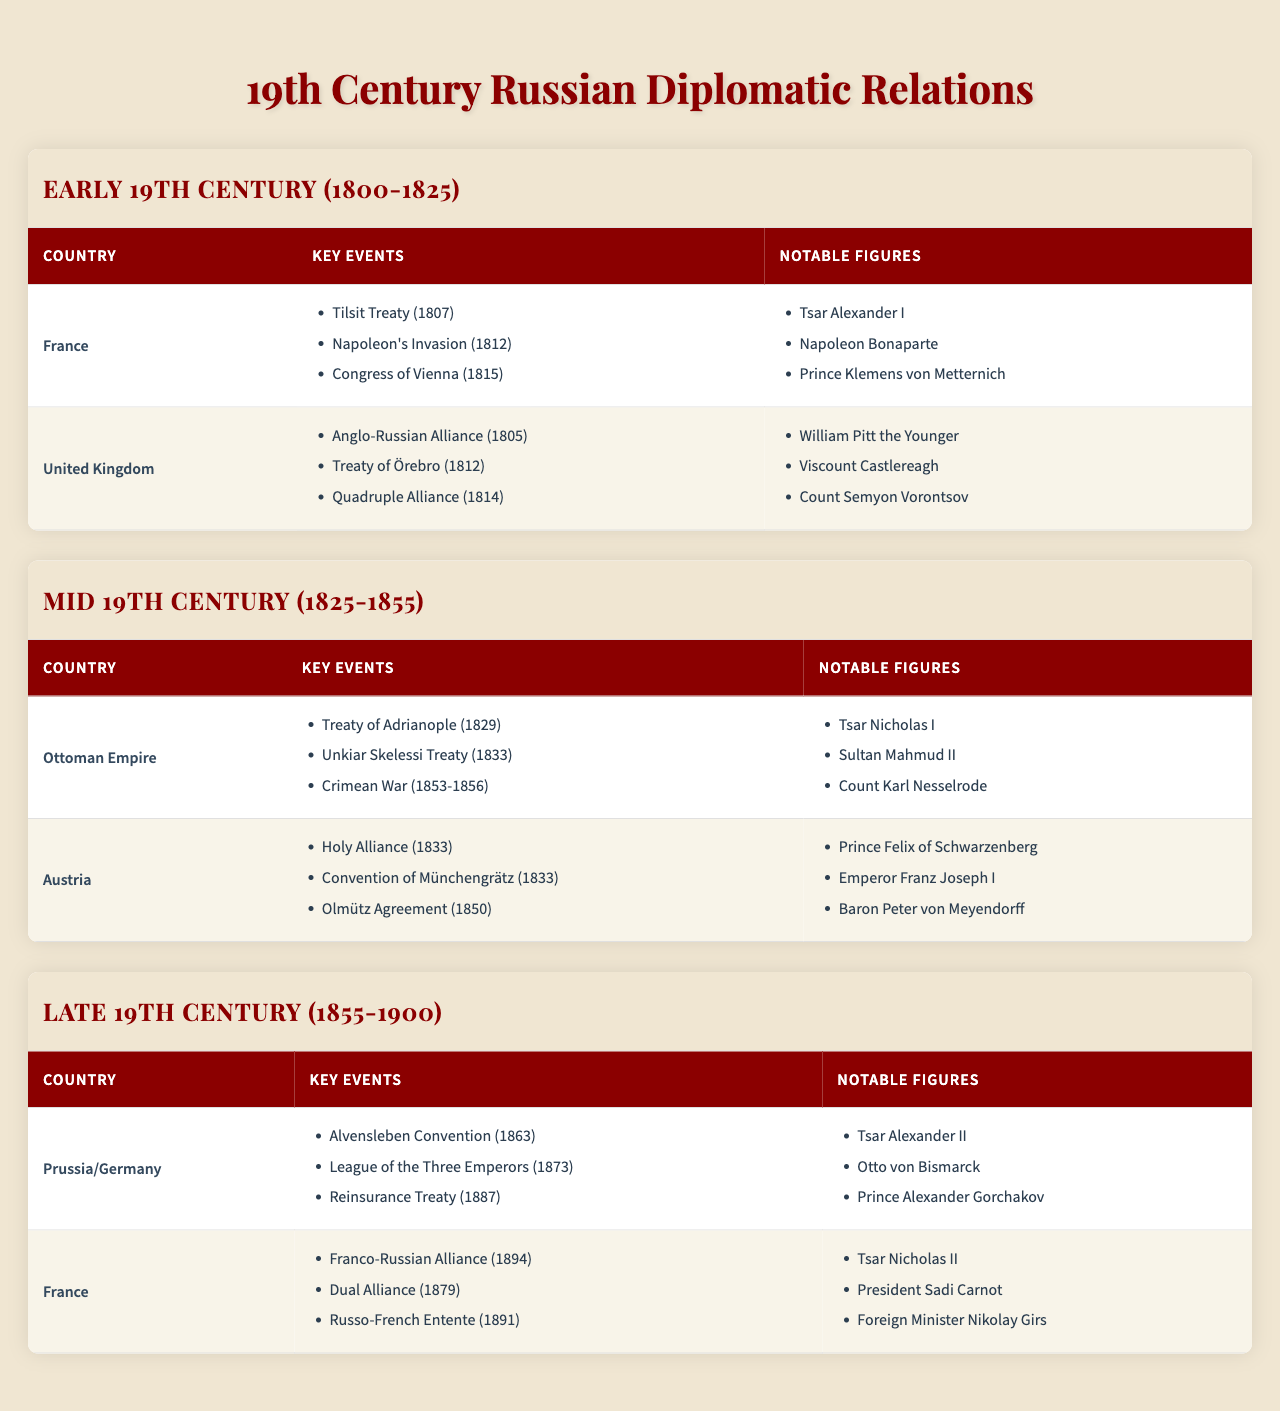What major treaty was signed between Russia and France in 1807? The table lists the key events in the early 19th century under the section for France, which includes the "Tilsit Treaty (1807)."
Answer: Tilsit Treaty Which notable figure was involved in the Treaty of Adrianople in 1829? The table indicates that the Treaty of Adrianople was signed during the mid 19th century, and under the Ottoman Empire, it lists "Tsar Nicholas I" as a notable figure.
Answer: Tsar Nicholas I Did the United Kingdom and Russia enter into any alliances during the early 19th century? Referring to the table under the United Kingdom section, it shows that they established the "Anglo-Russian Alliance (1805)." Therefore, yes, they did enter into alliances.
Answer: Yes How many key events are listed for Prussia/Germany in the late 19th century? Looking at the table under the section for Prussia/Germany, three key events are mentioned: "Alvensleben Convention (1863)," "League of the Three Emperors (1873)," and "Reinsurance Treaty (1887)."
Answer: Three Which two countries had notable figures such as Tsar Alexander II and Otto von Bismarck during the late 19th century? The notable figures listed under the Prussia/Germany section include Tsar Alexander II and Otto von Bismarck, indicating that the country in question is Prussia/Germany.
Answer: Prussia/Germany What were the notable figures associated with the Franco-Russian Alliance signed in 1894? The table specifies under the France section that notable figures during this time included "Tsar Nicholas II," "President Sadi Carnot," and "Foreign Minister Nikolay Girs."
Answer: Tsar Nicholas II, President Sadi Carnot, Foreign Minister Nikolay Girs Identify the treaties associated with the Ottoman Empire from 1829 to 1856. The table lists the key events for the Ottoman Empire as "Treaty of Adrianople (1829)," "Unkiar Skelessi Treaty (1833)," and "Crimean War (1853-1856)," indicating all the treaties during that period.
Answer: Treaty of Adrianople, Unkiar Skelessi Treaty, Crimean War What is the relationship between the Holy Alliance in 1833 and the notable figures from that period? The table includes the "Holy Alliance (1833)" event under Austria and lists notable figures like "Prince Felix of Schwarzenberg," "Emperor Franz Joseph I," and "Baron Peter von Meyendorff." This relationship highlights their participation in the alliance.
Answer: It indicates their participation in the alliance How did the diplomatic relations between Russia and Austria evolve from the early to the mid-19th century? Examining the table, in the early 19th century, Russia's notable events include the Quadruple Alliance in 1814 with Austria and by the mid-19th century, they continued cooperation through the Holy Alliance and the Olmütz Agreement, signifying a sustained yet evolving relationship.
Answer: They showed sustained cooperation that evolved over time Which country maintained a consistent diplomatic relationship with Russia throughout the 19th century? The table lists France in the early (Tilsit Treaty), late (Franco-Russian Alliance), and continues to show consistent relations, indicating that France maintained a consistent relationship with Russia.
Answer: France 